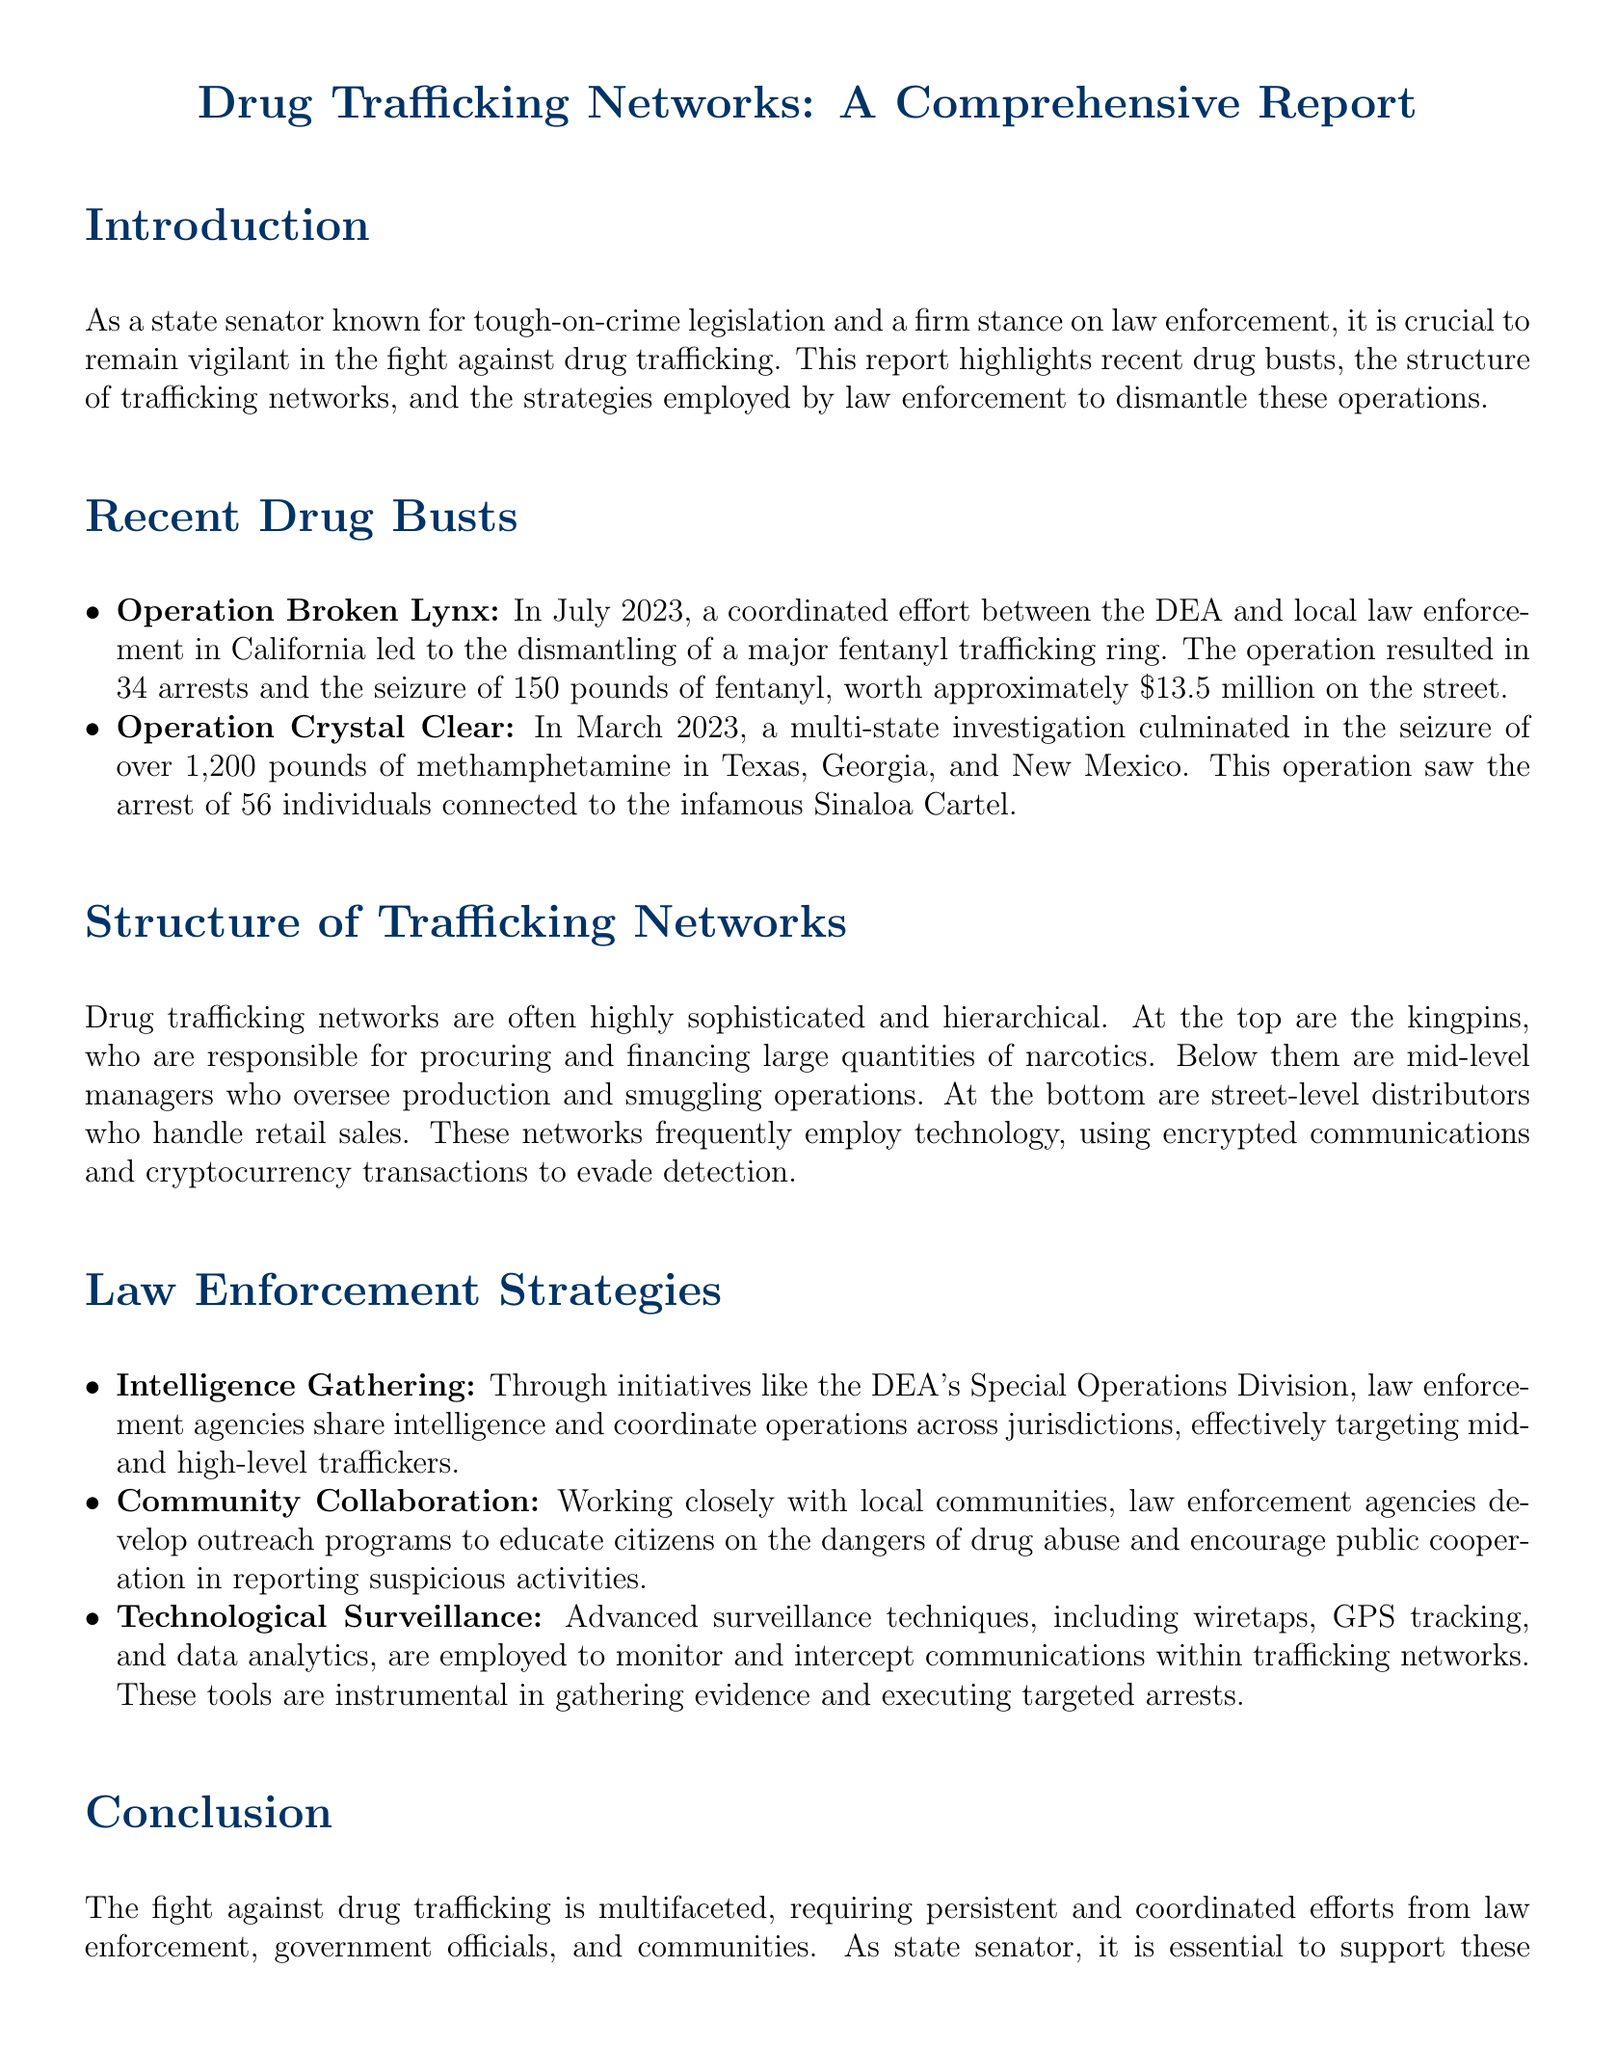what was the name of the operation that dismantled a fentanyl trafficking ring? The report mentions "Operation Broken Lynx" as the operation that led to the dismantling of a major fentanyl trafficking ring in July 2023.
Answer: Operation Broken Lynx how many arrests were made during Operation Crystal Clear? The document states that 56 individuals were arrested in a multi-state investigation known as Operation Crystal Clear.
Answer: 56 what type of narcotics was seized in Operation Broken Lynx? According to the report, 150 pounds of fentanyl were seized during Operation Broken Lynx.
Answer: fentanyl what organization was involved in the drug trafficking operation mentioned in Operation Crystal Clear? The report identifies the infamous Sinaloa Cartel as being connected to the operation that seized methamphetamine.
Answer: Sinaloa Cartel which surveillance techniques are mentioned as being employed by law enforcement? The document lists wiretaps, GPS tracking, and data analytics as advanced surveillance techniques used by law enforcement.
Answer: wiretaps, GPS tracking, data analytics who are at the top of drug trafficking networks according to the document? The report describes the top tier of drug trafficking networks as being kingpins responsible for procuring and financing narcotics.
Answer: kingpins what is the purpose of the DEA's Special Operations Division? The document mentions that the DEA's Special Operations Division is aimed at sharing intelligence and coordinating operations across jurisdictions to effectively target traffickers.
Answer: sharing intelligence and coordinating operations how does law enforcement engage with local communities? The report indicates that law enforcement develops outreach programs to educate citizens on drug abuse and encourage public cooperation.
Answer: outreach programs what was the worth of the fentanyl seized in Operation Broken Lynx? The report states that the worth of the 150 pounds of fentanyl seized in the operation was approximately $13.5 million.
Answer: $13.5 million 